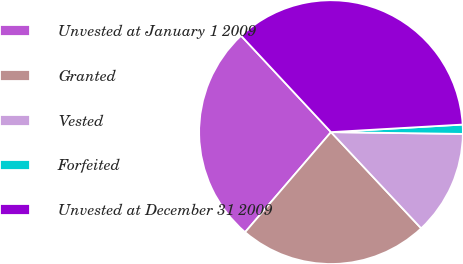Convert chart. <chart><loc_0><loc_0><loc_500><loc_500><pie_chart><fcel>Unvested at January 1 2009<fcel>Granted<fcel>Vested<fcel>Forfeited<fcel>Unvested at December 31 2009<nl><fcel>26.76%<fcel>23.27%<fcel>12.8%<fcel>1.13%<fcel>36.03%<nl></chart> 